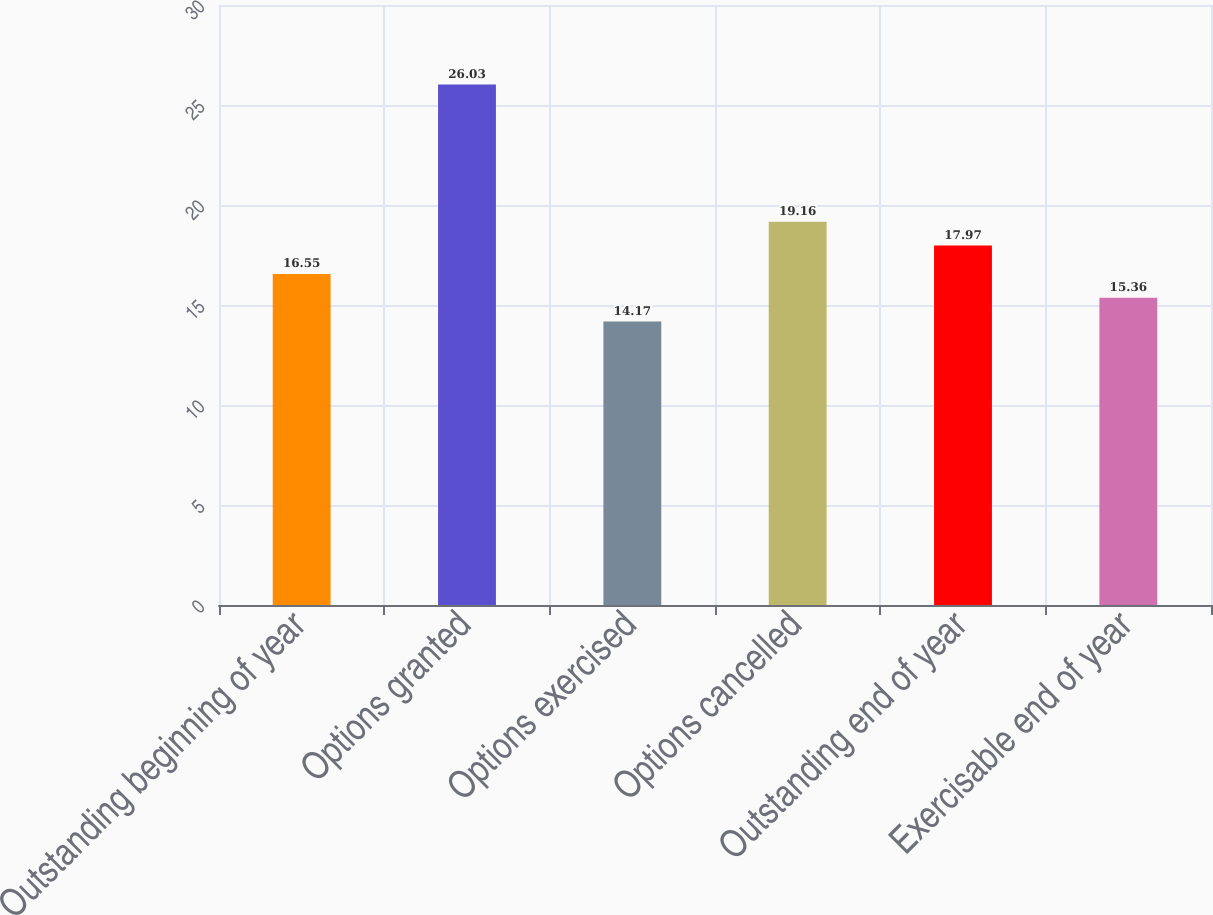Convert chart to OTSL. <chart><loc_0><loc_0><loc_500><loc_500><bar_chart><fcel>Outstanding beginning of year<fcel>Options granted<fcel>Options exercised<fcel>Options cancelled<fcel>Outstanding end of year<fcel>Exercisable end of year<nl><fcel>16.55<fcel>26.03<fcel>14.17<fcel>19.16<fcel>17.97<fcel>15.36<nl></chart> 